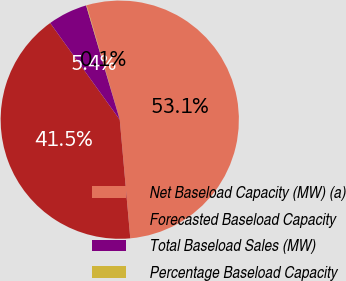<chart> <loc_0><loc_0><loc_500><loc_500><pie_chart><fcel>Net Baseload Capacity (MW) (a)<fcel>Forecasted Baseload Capacity<fcel>Total Baseload Sales (MW)<fcel>Percentage Baseload Capacity<nl><fcel>53.09%<fcel>41.48%<fcel>5.37%<fcel>0.06%<nl></chart> 